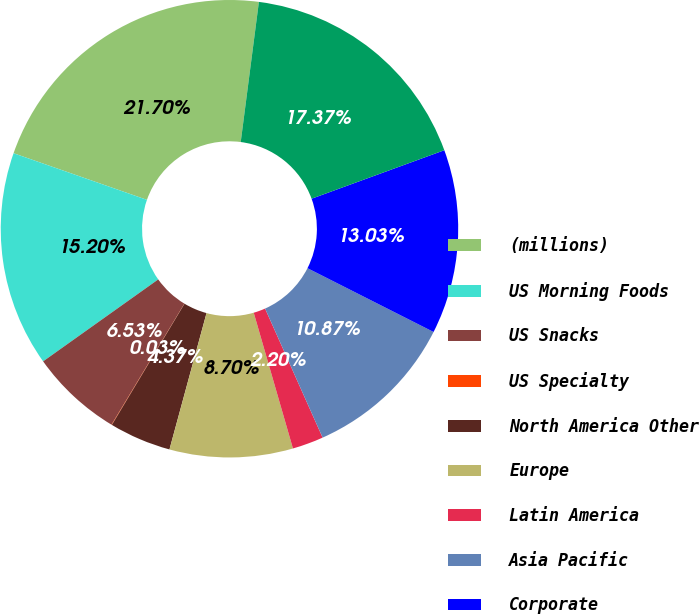Convert chart to OTSL. <chart><loc_0><loc_0><loc_500><loc_500><pie_chart><fcel>(millions)<fcel>US Morning Foods<fcel>US Snacks<fcel>US Specialty<fcel>North America Other<fcel>Europe<fcel>Latin America<fcel>Asia Pacific<fcel>Corporate<fcel>Total<nl><fcel>21.7%<fcel>15.2%<fcel>6.53%<fcel>0.03%<fcel>4.37%<fcel>8.7%<fcel>2.2%<fcel>10.87%<fcel>13.03%<fcel>17.37%<nl></chart> 